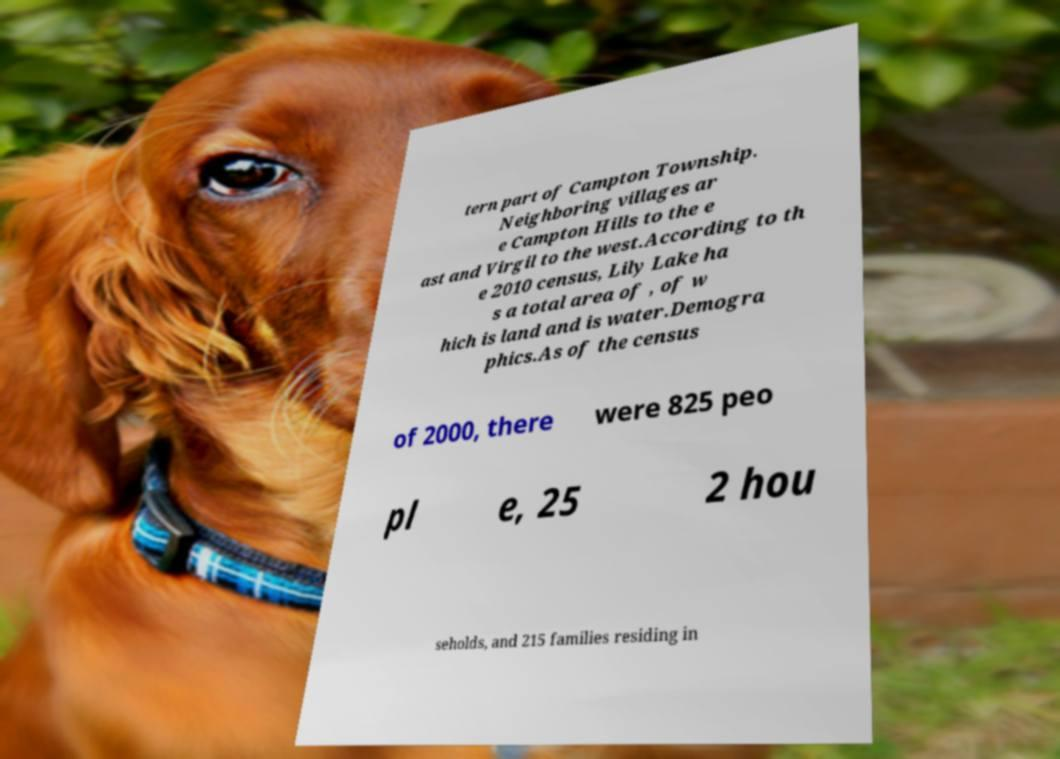There's text embedded in this image that I need extracted. Can you transcribe it verbatim? tern part of Campton Township. Neighboring villages ar e Campton Hills to the e ast and Virgil to the west.According to th e 2010 census, Lily Lake ha s a total area of , of w hich is land and is water.Demogra phics.As of the census of 2000, there were 825 peo pl e, 25 2 hou seholds, and 215 families residing in 